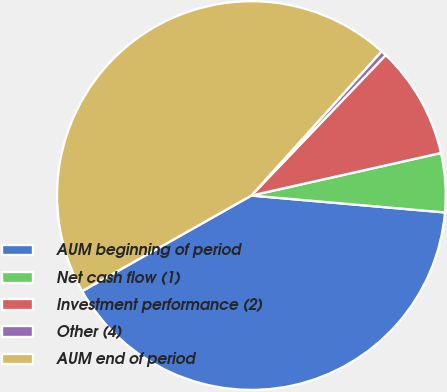Convert chart. <chart><loc_0><loc_0><loc_500><loc_500><pie_chart><fcel>AUM beginning of period<fcel>Net cash flow (1)<fcel>Investment performance (2)<fcel>Other (4)<fcel>AUM end of period<nl><fcel>40.43%<fcel>4.9%<fcel>9.34%<fcel>0.46%<fcel>44.87%<nl></chart> 